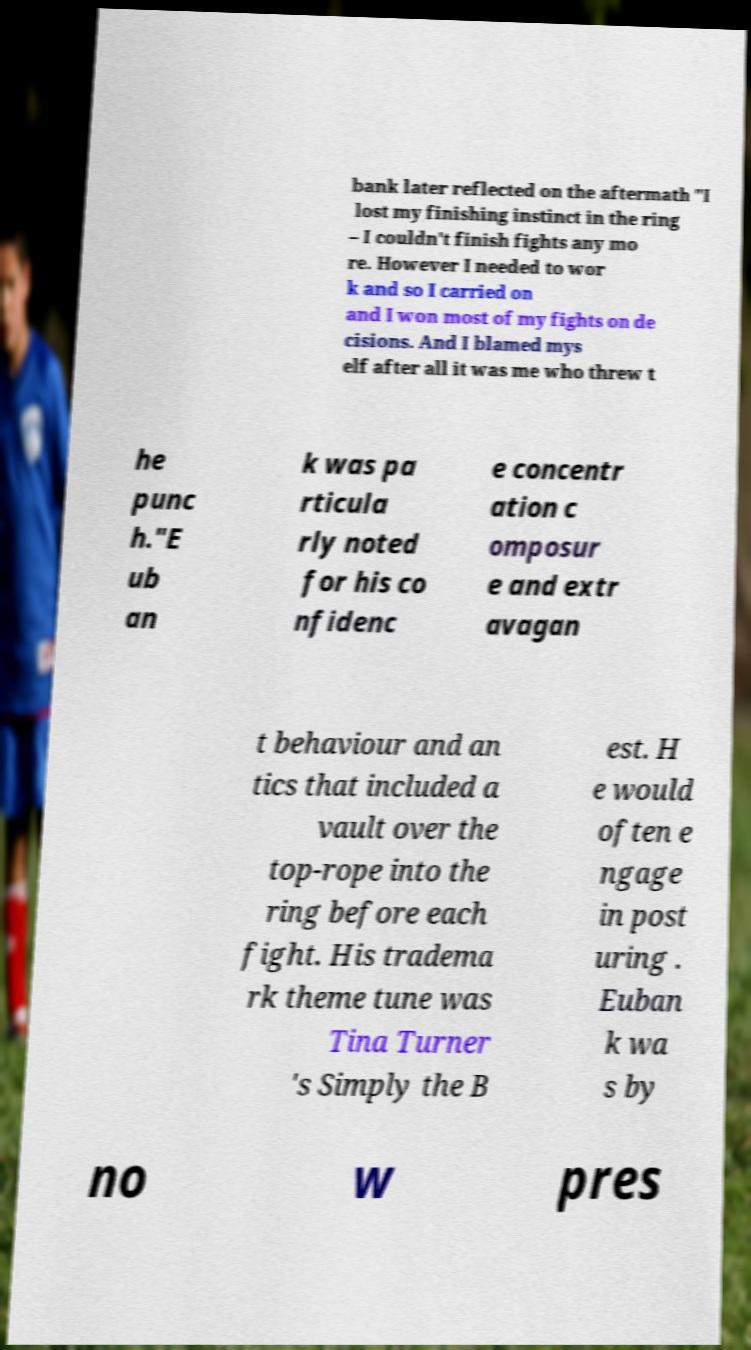What messages or text are displayed in this image? I need them in a readable, typed format. bank later reflected on the aftermath "I lost my finishing instinct in the ring – I couldn't finish fights any mo re. However I needed to wor k and so I carried on and I won most of my fights on de cisions. And I blamed mys elf after all it was me who threw t he punc h."E ub an k was pa rticula rly noted for his co nfidenc e concentr ation c omposur e and extr avagan t behaviour and an tics that included a vault over the top-rope into the ring before each fight. His tradema rk theme tune was Tina Turner 's Simply the B est. H e would often e ngage in post uring . Euban k wa s by no w pres 